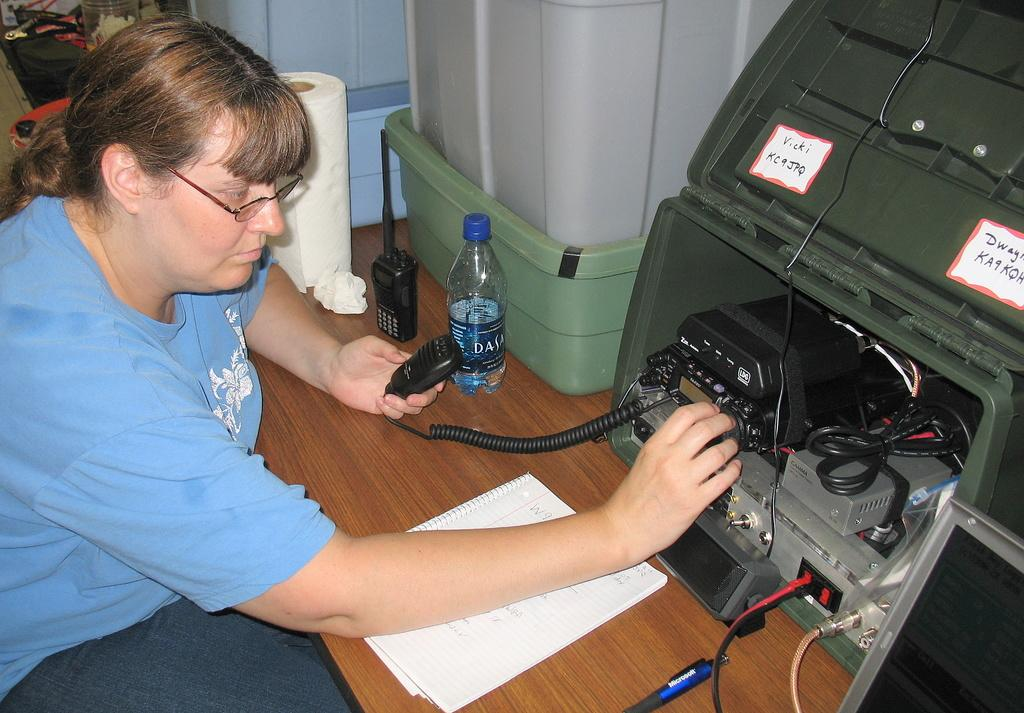<image>
Render a clear and concise summary of the photo. the lady has a bottle of Dasani water on her desk 